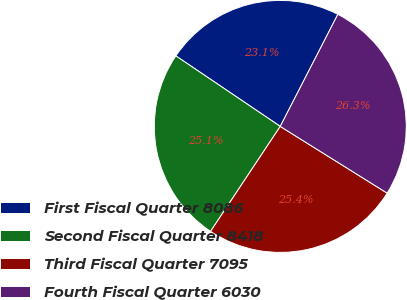<chart> <loc_0><loc_0><loc_500><loc_500><pie_chart><fcel>First Fiscal Quarter 8086<fcel>Second Fiscal Quarter 8418<fcel>Third Fiscal Quarter 7095<fcel>Fourth Fiscal Quarter 6030<nl><fcel>23.1%<fcel>25.13%<fcel>25.45%<fcel>26.33%<nl></chart> 